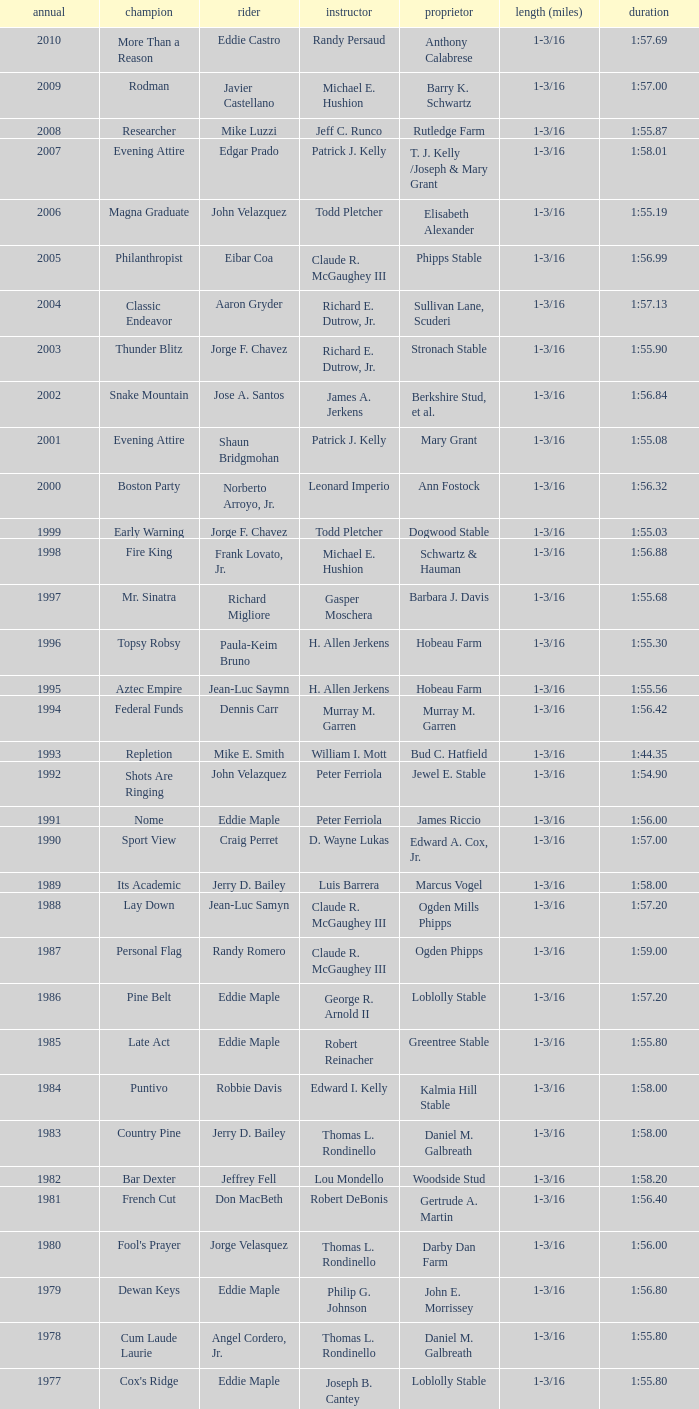When the winner was No Race in a year after 1909, what was the distance? 1 mile, 1 mile, 1 mile. 